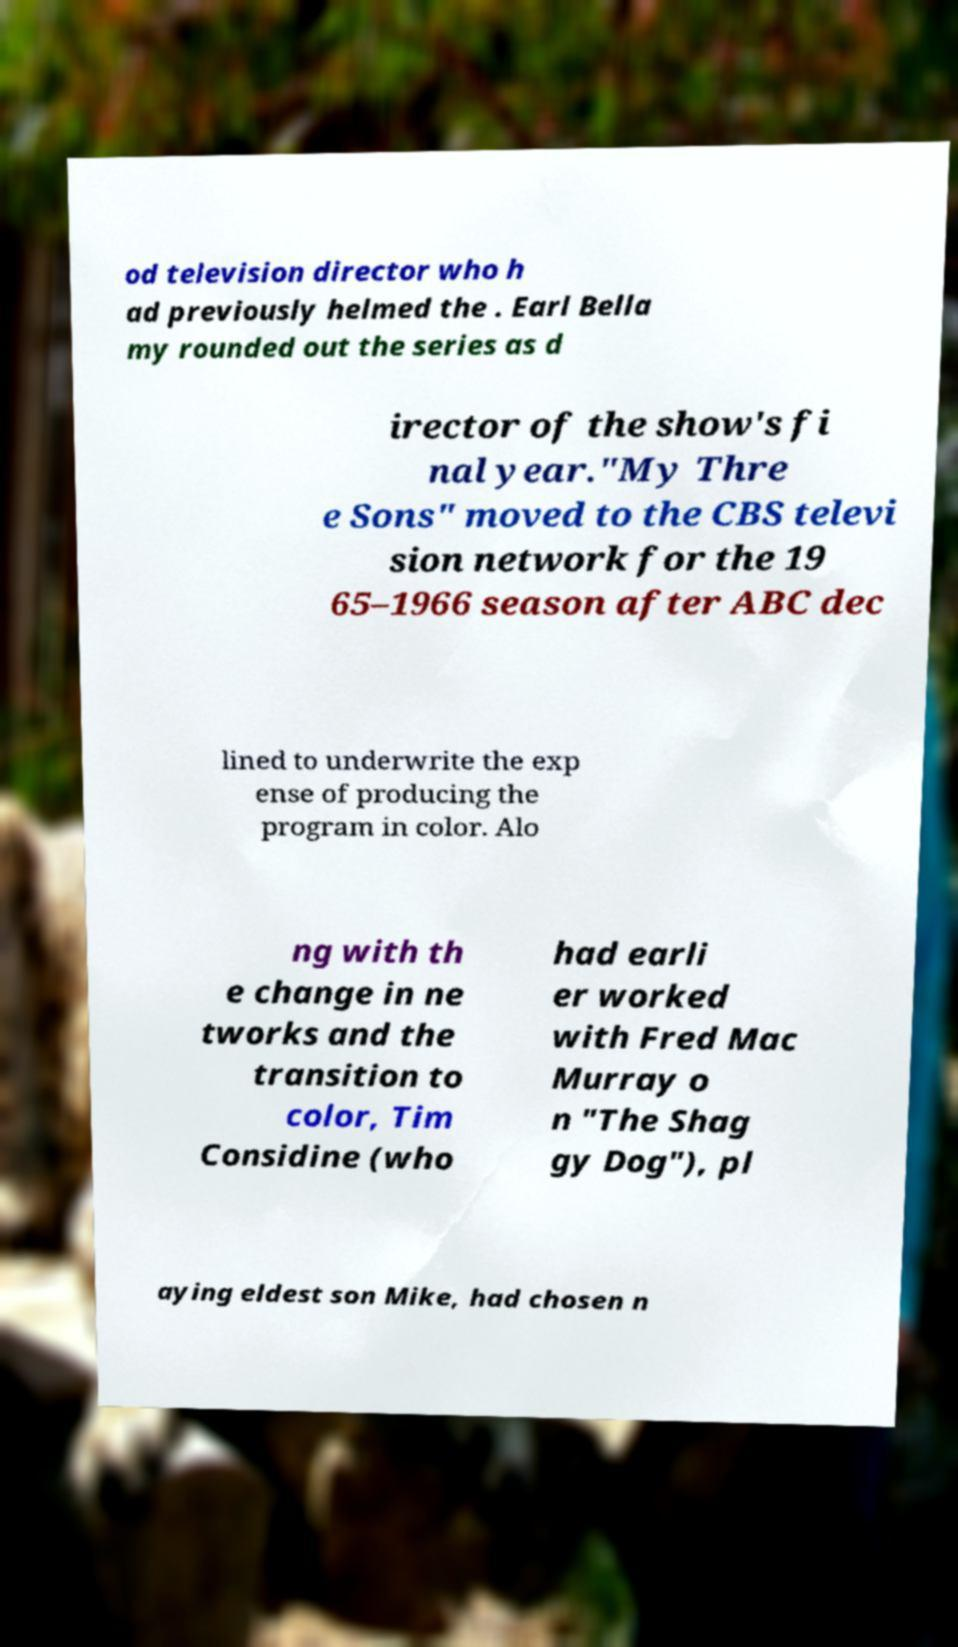Please read and relay the text visible in this image. What does it say? od television director who h ad previously helmed the . Earl Bella my rounded out the series as d irector of the show's fi nal year."My Thre e Sons" moved to the CBS televi sion network for the 19 65–1966 season after ABC dec lined to underwrite the exp ense of producing the program in color. Alo ng with th e change in ne tworks and the transition to color, Tim Considine (who had earli er worked with Fred Mac Murray o n "The Shag gy Dog"), pl aying eldest son Mike, had chosen n 